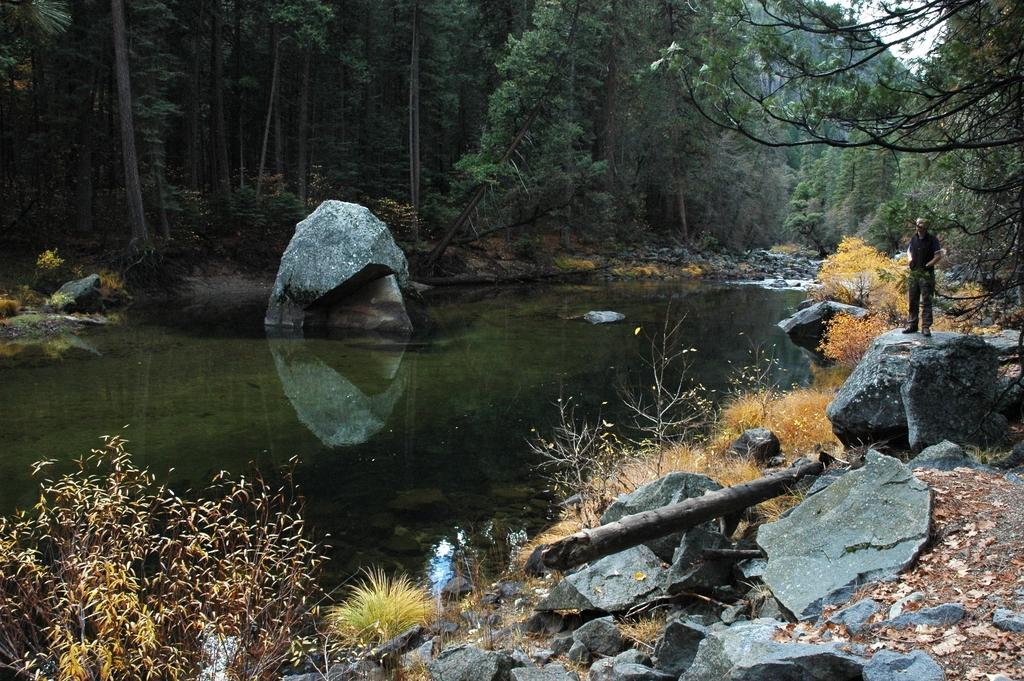What is one of the natural elements present in the image? There is water in the image. What type of vegetation can be seen in the image? There is grass, plants, and trees in the image. What type of terrain is visible in the image? There are rocks in the image. What is the person in the image doing? A person is standing on a rock. What is visible in the background of the image? There are trees and the sky in the background of the image. What type of fuel is being used by the person standing on the rock in the image? There is no indication of any fuel being used in the image; the person is simply standing on a rock. What type of metal can be seen in the image? There is no metal present in the image. 